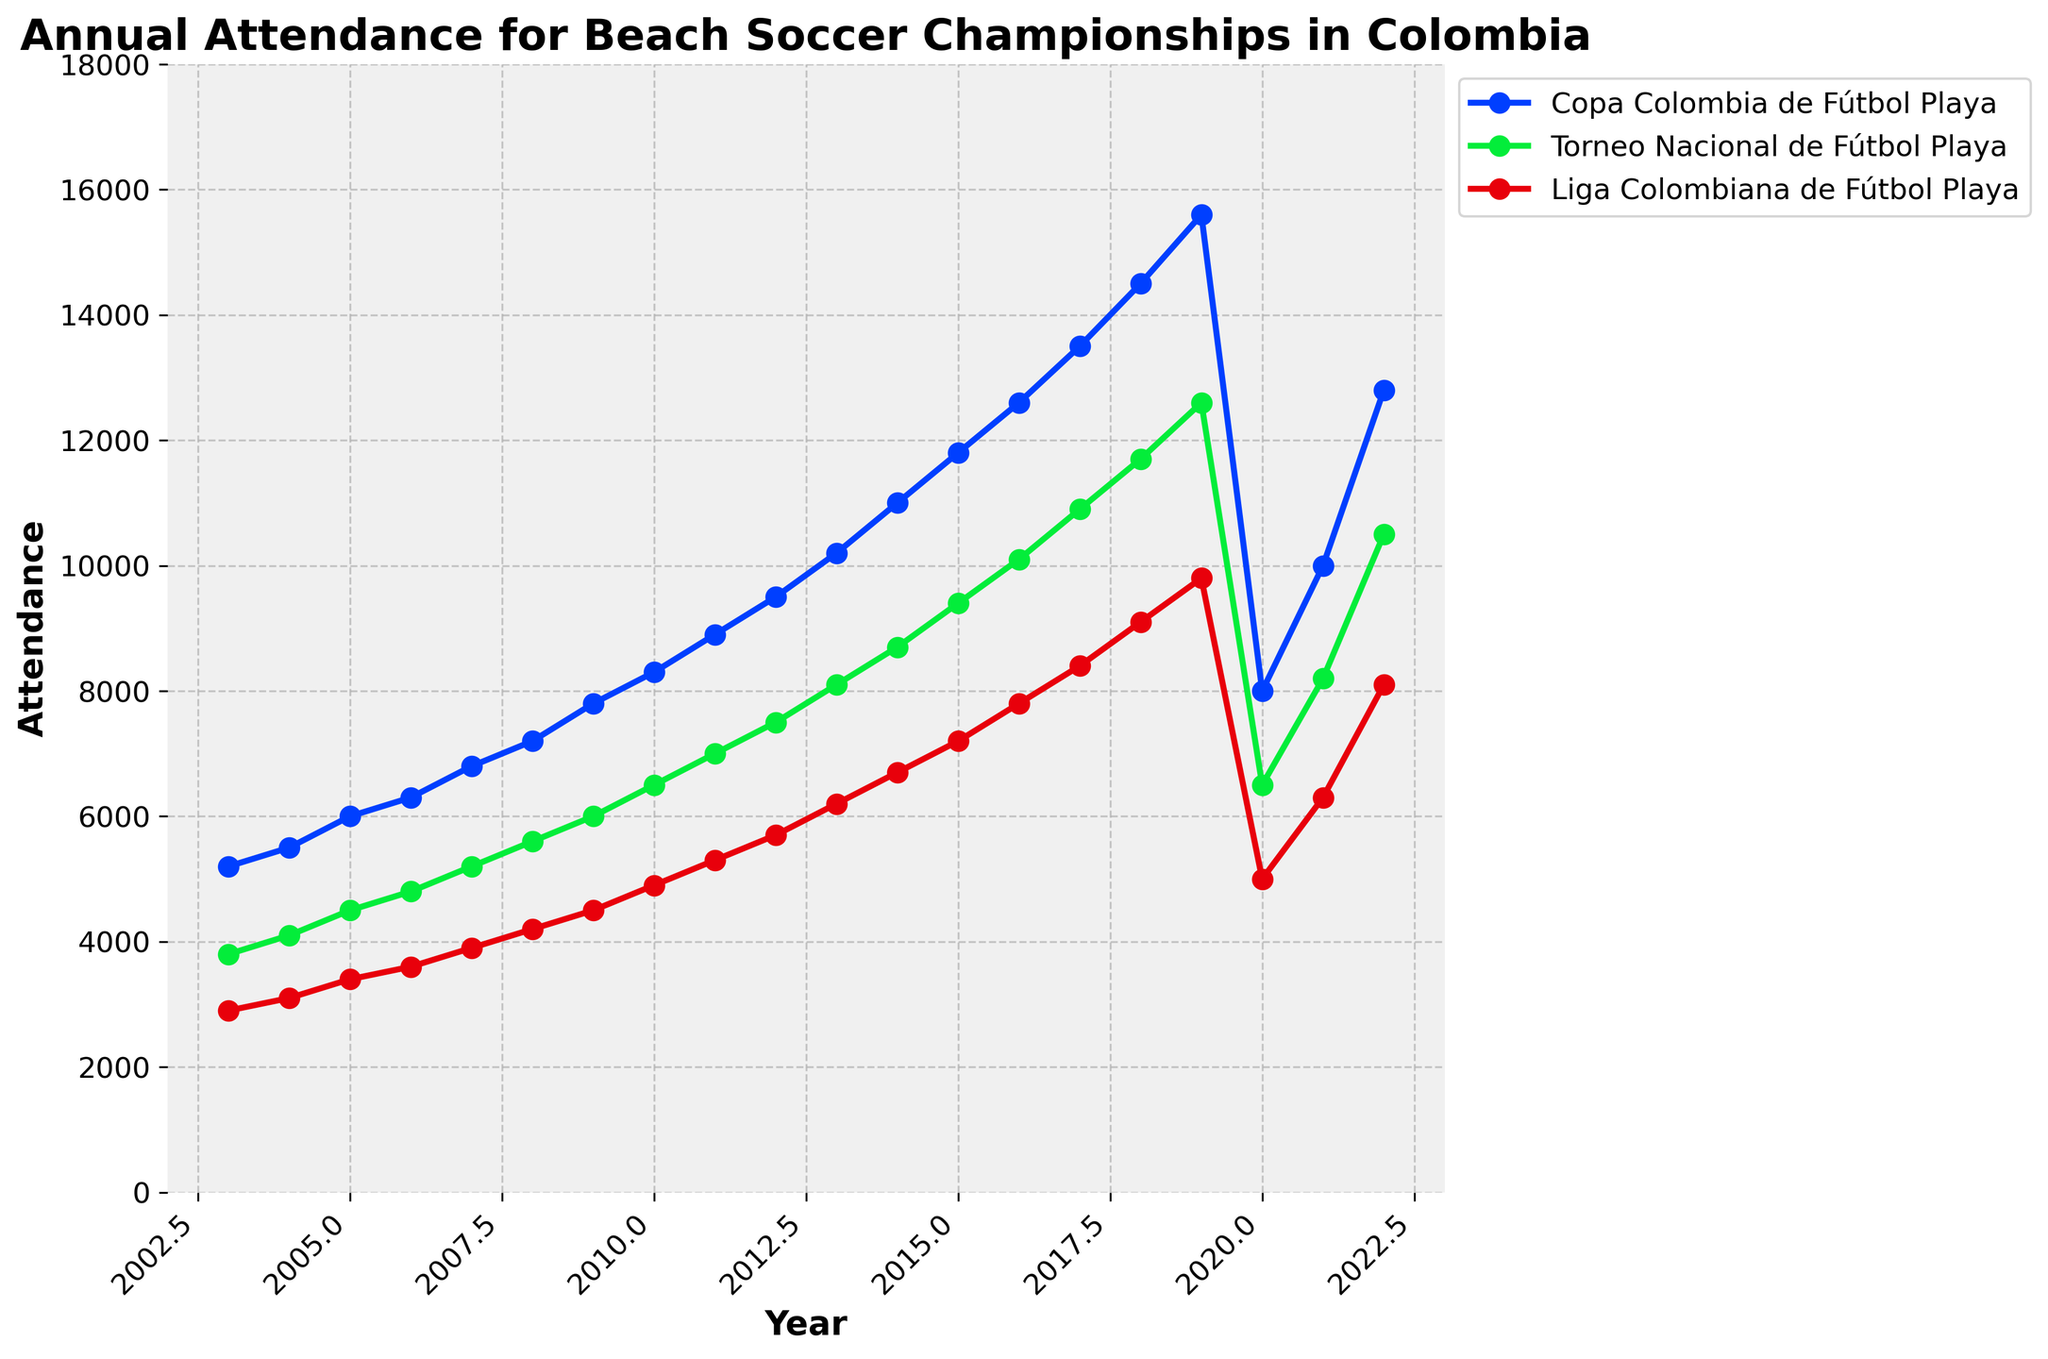What's the overall trend in attendance for the Copa Colombia de Fútbol Playa from 2003 to 2022? Attendance for the Copa Colombia de Fútbol Playa generally increased from 5200 in 2003 to 15600 in 2019, with a significant drop to 8000 in 2020, followed by a rebound to 12800 in 2022.
Answer: Increasing with a dip in 2020 Which year had the highest attendance for the Torneo Nacional de Fútbol Playa? The highest attendance for the Torneo Nacional de Fútbol Playa is at its peak in 2019 with 12600 attendees.
Answer: 2019 How did the attendance for the Liga Colombiana de Fútbol Playa change from 2019 to 2020? The attendance for the Liga Colombiana de Fútbol Playa decreased from 9800 in 2019 to 5000 in 2020.
Answer: Decreased In which year did all three championships have their lowest attendance? In 2020, all three championships had their lowest attendance: 8000 (Copa Colombia de Fútbol Playa), 6500 (Torneo Nacional de Fútbol Playa), and 5000 (Liga Colombiana de Fútbol Playa).
Answer: 2020 Compare the attendance change for Copa Colombia de Fútbol Playa and Liga Colombiana de Fútbol Playa between 2021 and 2022. For Copa Colombia de Fútbol Playa, the attendance increased from 10000 in 2021 to 12800 in 2022 (an increase of 2800); for Liga Colombiana de Fútbol Playa, it increased from 6300 in 2021 to 8100 in 2022 (an increase of 1800).
Answer: Both increased, 2800 (Copa) and 1800 (Liga) What was the average attendance for the Torneo Nacional de Fútbol Playa between 2018 and 2022? The attendance figures for those years are 11700, 12600, 6500, 8200, and 10500; the average is (11700 + 12600 + 6500 + 8200 + 10500) / 5 = 49500 / 5 = 9900.
Answer: 9900 How does the attendance in 2013 compare across the three championships? In 2013, the attendance was 10200 for Copa Colombia de Fútbol Playa, 8100 for Torneo Nacional de Fútbol Playa, and 6200 for Liga Colombiana de Fútbol Playa, with Copa having the highest and Liga the lowest.
Answer: Copa > Torneo > Liga Which championship had the most consistent growth from 2003 to 2019? By visual inspection, Copa Colombia de Fútbol Playa shows a steady increase almost every year from 5200 in 2003 to 15600 in 2019, indicating the most consistent growth.
Answer: Copa Colombia de Fútbol Playa What's the total attendance for Copa Colombia de Fútbol Playa across all the years shown? Summing the attendance figures for Copa in all years: 5200 + 5500 + 6000 + 6300 + 6800 + 7200 + 7800 + 8300 + 8900 + 9500 + 10200 + 11000 + 11800 + 12600 + 13500 + 14500 + 15600 + 8000 + 10000 + 12800 = 208500.
Answer: 208500 What is the difference in attendance between the Copa Colombia de Fútbol Playa and the Liga Colombiana de Fútbol Playa in 2022? For 2022, Copa Colombia de Fútbol Playa had 12800 attendees, and Liga Colombiana de Fútbol Playa had 8100 attendees; the difference is 12800 - 8100 = 4700.
Answer: 4700 